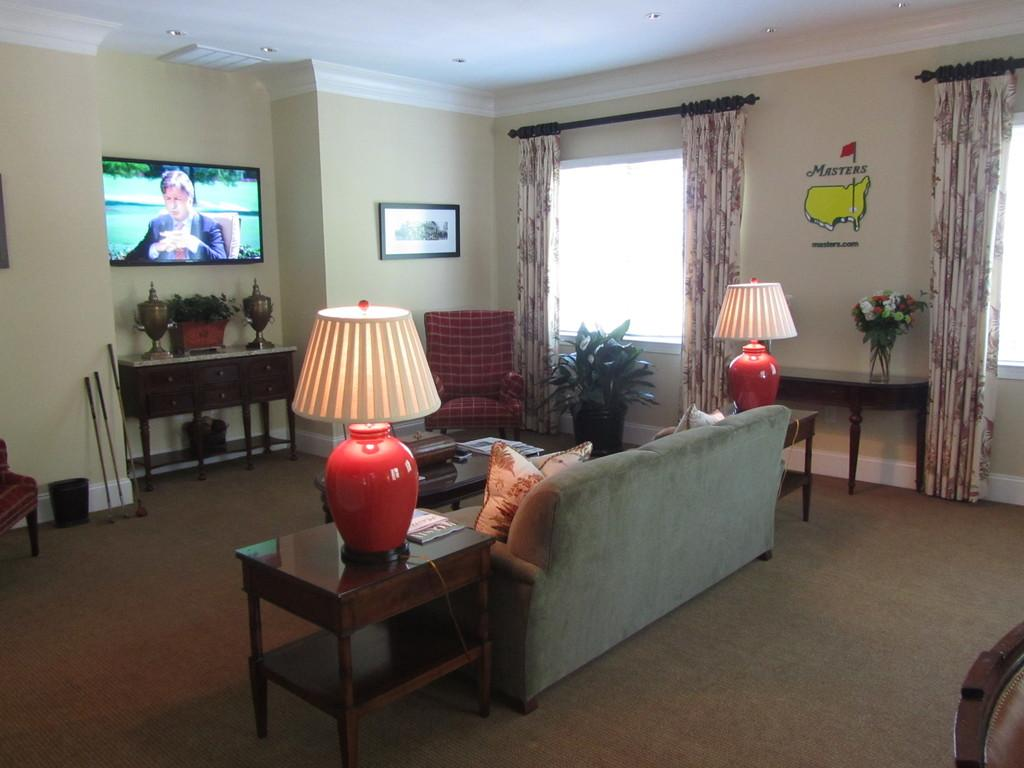What type of furniture is present in the image? There is a sofa and a chair in the image. What can be found on the sofa? There are cushions on the sofa. How many lamps are visible in the image? There are two lamps in the image. What type of greenery is present in the image? There is a plant in the image. What type of entertainment device is present in the image? There is a television in the image. What is hanging on the wall in the image? There is a frame on the wall. Can you see any friends or donkeys in the image? No, there are no friends or donkeys present in the image. Is there an airplane visible in the image? No, there is no airplane present in the image. 